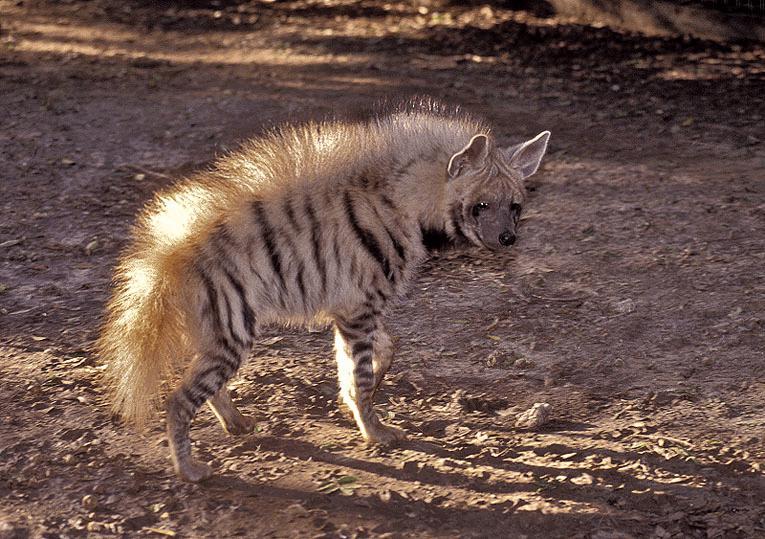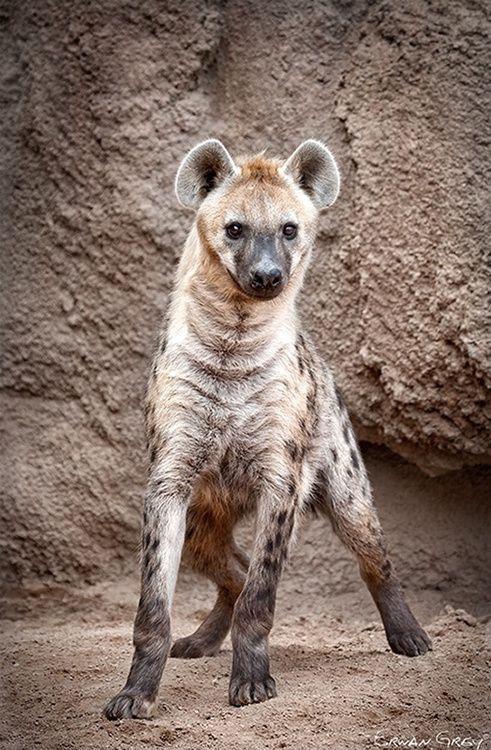The first image is the image on the left, the second image is the image on the right. For the images displayed, is the sentence "An image shows a closely grouped trio of hyenas looking at the camera, all with closed mouths." factually correct? Answer yes or no. No. The first image is the image on the left, the second image is the image on the right. Given the left and right images, does the statement "There's no more than one hyena in the right image." hold true? Answer yes or no. Yes. 